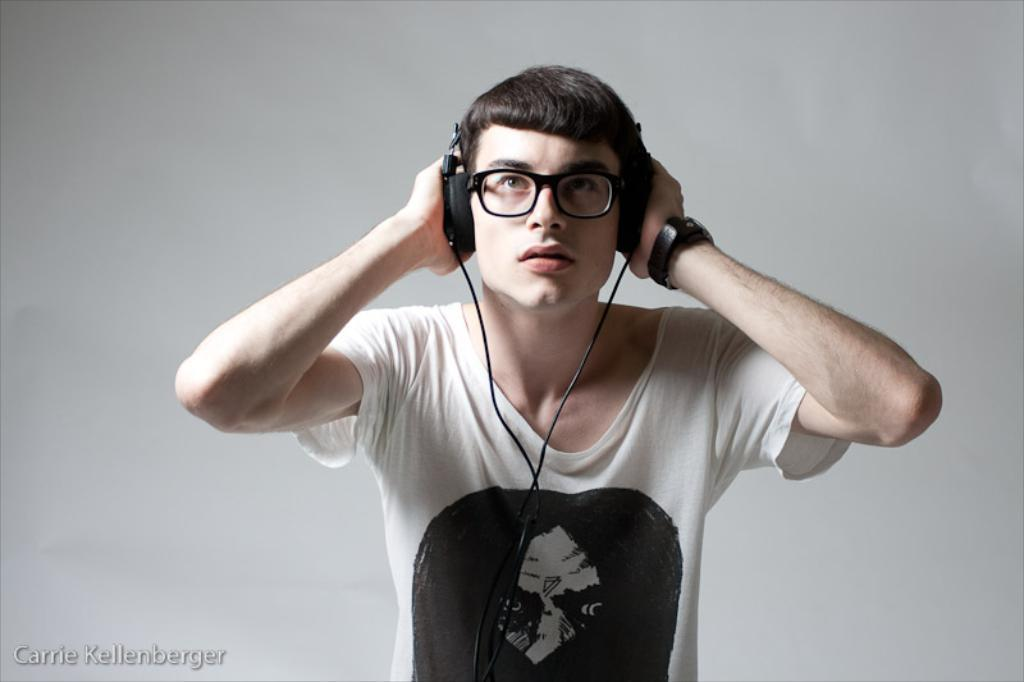What is the main subject of the image? The main subject of the image is a man. What is the man wearing on his upper body? The man is wearing a white T-shirt. What type of accessory is the man wearing on his head? The man is wearing headphones. What type of accessory is the man wearing on his wrist? The man is wearing a watch. How many dogs are visible in the image? There are no dogs present in the image. What type of cart is the man pushing in the image? There is no cart present in the image. 